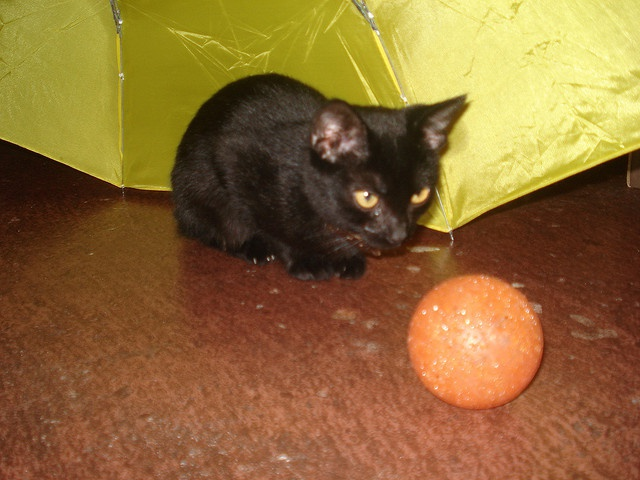Describe the objects in this image and their specific colors. I can see umbrella in maroon, olive, and khaki tones, cat in olive, black, maroon, and gray tones, and sports ball in olive, orange, red, brown, and tan tones in this image. 